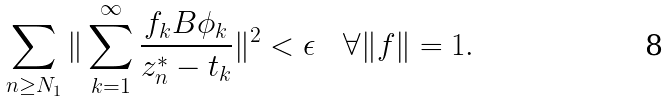Convert formula to latex. <formula><loc_0><loc_0><loc_500><loc_500>\sum _ { n \geq N _ { 1 } } \| \sum _ { k = 1 } ^ { \infty } \frac { f _ { k } B \phi _ { k } } { z ^ { * } _ { n } - t _ { k } } \| ^ { 2 } < \epsilon \quad \forall \| f \| = 1 .</formula> 